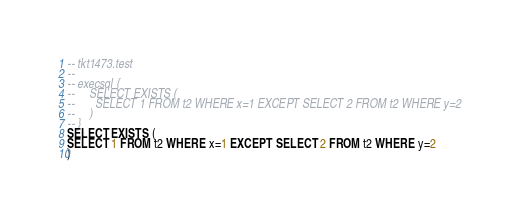<code> <loc_0><loc_0><loc_500><loc_500><_SQL_>-- tkt1473.test
-- 
-- execsql {
--     SELECT EXISTS (
--       SELECT 1 FROM t2 WHERE x=1 EXCEPT SELECT 2 FROM t2 WHERE y=2
--     )
-- }
SELECT EXISTS (
SELECT 1 FROM t2 WHERE x=1 EXCEPT SELECT 2 FROM t2 WHERE y=2
)</code> 